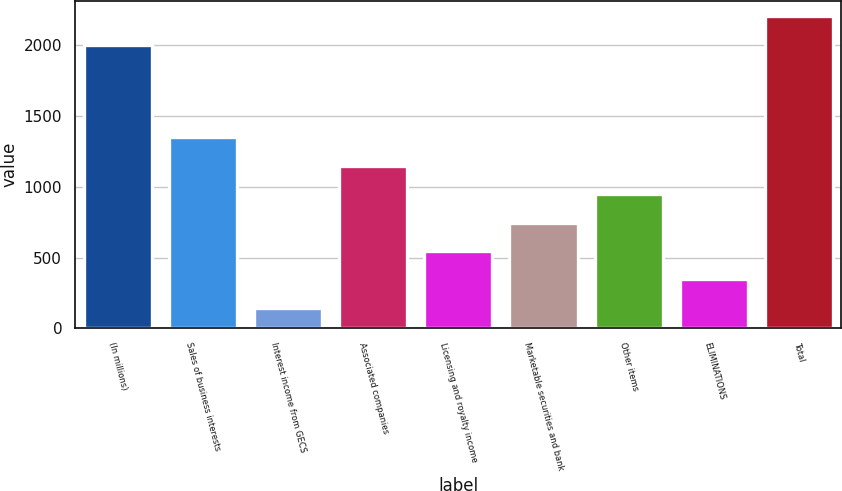Convert chart to OTSL. <chart><loc_0><loc_0><loc_500><loc_500><bar_chart><fcel>(In millions)<fcel>Sales of business interests<fcel>Interest income from GECS<fcel>Associated companies<fcel>Licensing and royalty income<fcel>Marketable securities and bank<fcel>Other items<fcel>ELIMINATIONS<fcel>Total<nl><fcel>2006<fcel>1350.4<fcel>145<fcel>1149.5<fcel>546.8<fcel>747.7<fcel>948.6<fcel>345.9<fcel>2206.9<nl></chart> 